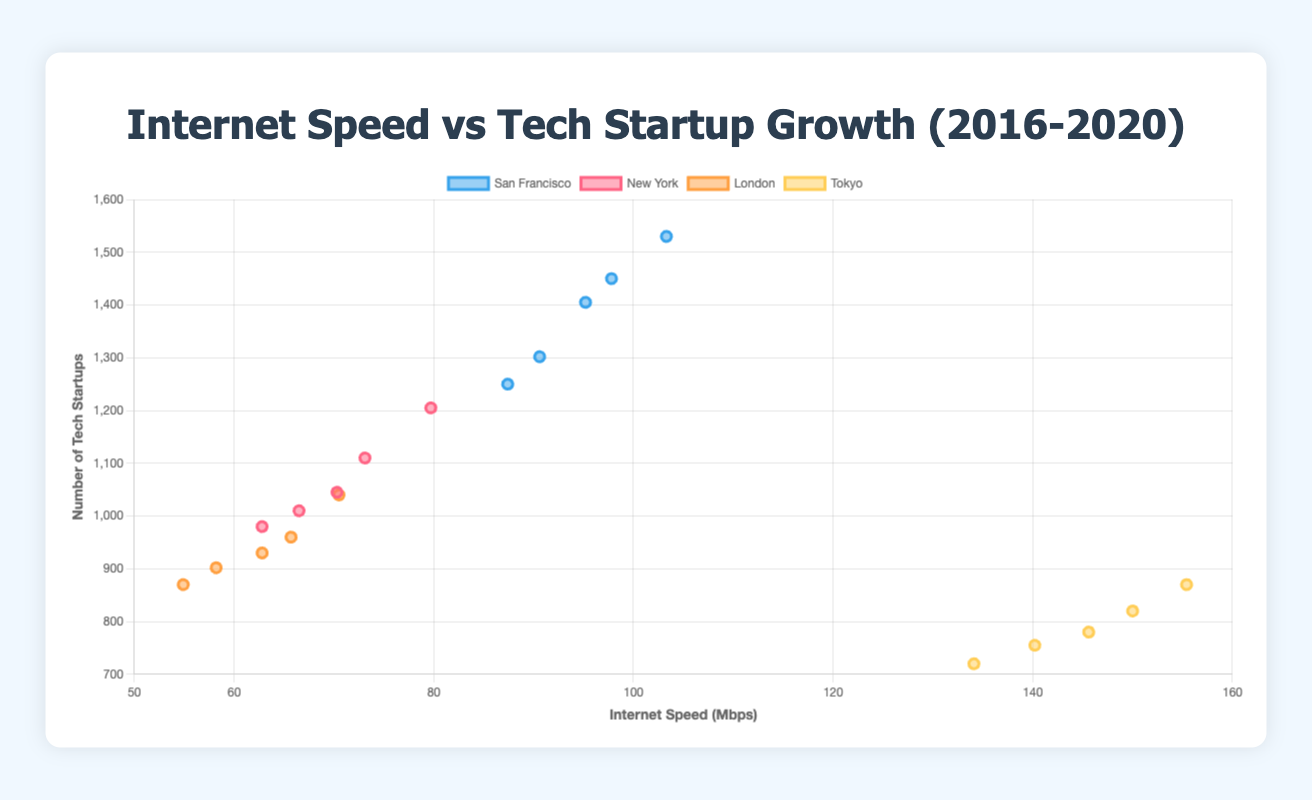What's the trend in startup growth in San Francisco from 2016 to 2020? Looking at the trend lines for San Francisco in the plot, we can see that the number of startups consistently increased each year from 1250 in 2016 to 1530 in 2020.
Answer: Increasing What was the highest internet speed recorded in Tokyo over the years shown, and in which year? By examining Tokyo's data points, the highest internet speed recorded is 155.4 Mbps in the year 2020.
Answer: 155.4 Mbps, 2020 Which city had the lowest startup count in 2020? Comparison of data points for the year 2020 shows that Tokyo had the lowest startup count among the listed cities with 870 startups.
Answer: Tokyo Between 2018 and 2019, did the internet speed in London increase or decrease, and by how much? The internet speed in London increased from 62.8 Mbps in 2018 to 65.7 Mbps in 2019. The increase is 65.7 - 62.8 = 2.9 Mbps.
Answer: Increase, 2.9 Mbps Which city experienced an increase in both internet speed and startup count every year from 2016 to 2020? By analyzing the trends, San Francisco consistently shows an increase in both internet speed and startup count every year from 2016 to 2020.
Answer: San Francisco What is the average internet speed in New York over the years 2016 to 2020? Sum of New York's internet speeds over the given years is (62.8 + 66.5 + 70.3 + 73.1 + 79.7) = 352.4 Mbps. The average is 352.4 Mbps / 5 years = 70.48 Mbps.
Answer: 70.48 Mbps Comparing 2018 and 2020, which city shows the highest growth in the number of tech startups? San Francisco shows the most significant growth in the number of startups from 2018 to 2020, increasing from 1405 to 1530 startups, a growth of 125 startups.
Answer: San Francisco What is the correlation between internet speed and startup count in London in 2020? In the plot, London in 2020 is represented by a point with 70.5 Mbps internet speed and 1040 startups indicating that higher internet speed correlates with a higher number of startups.
Answer: Positive correlation Which city's internet speed is below 100 Mbps throughout all the years presented? Referring to the plot, New York and London are the only cities with internet speeds consistently below 100 Mbps from 2016 to 2020.
Answer: New York, London 